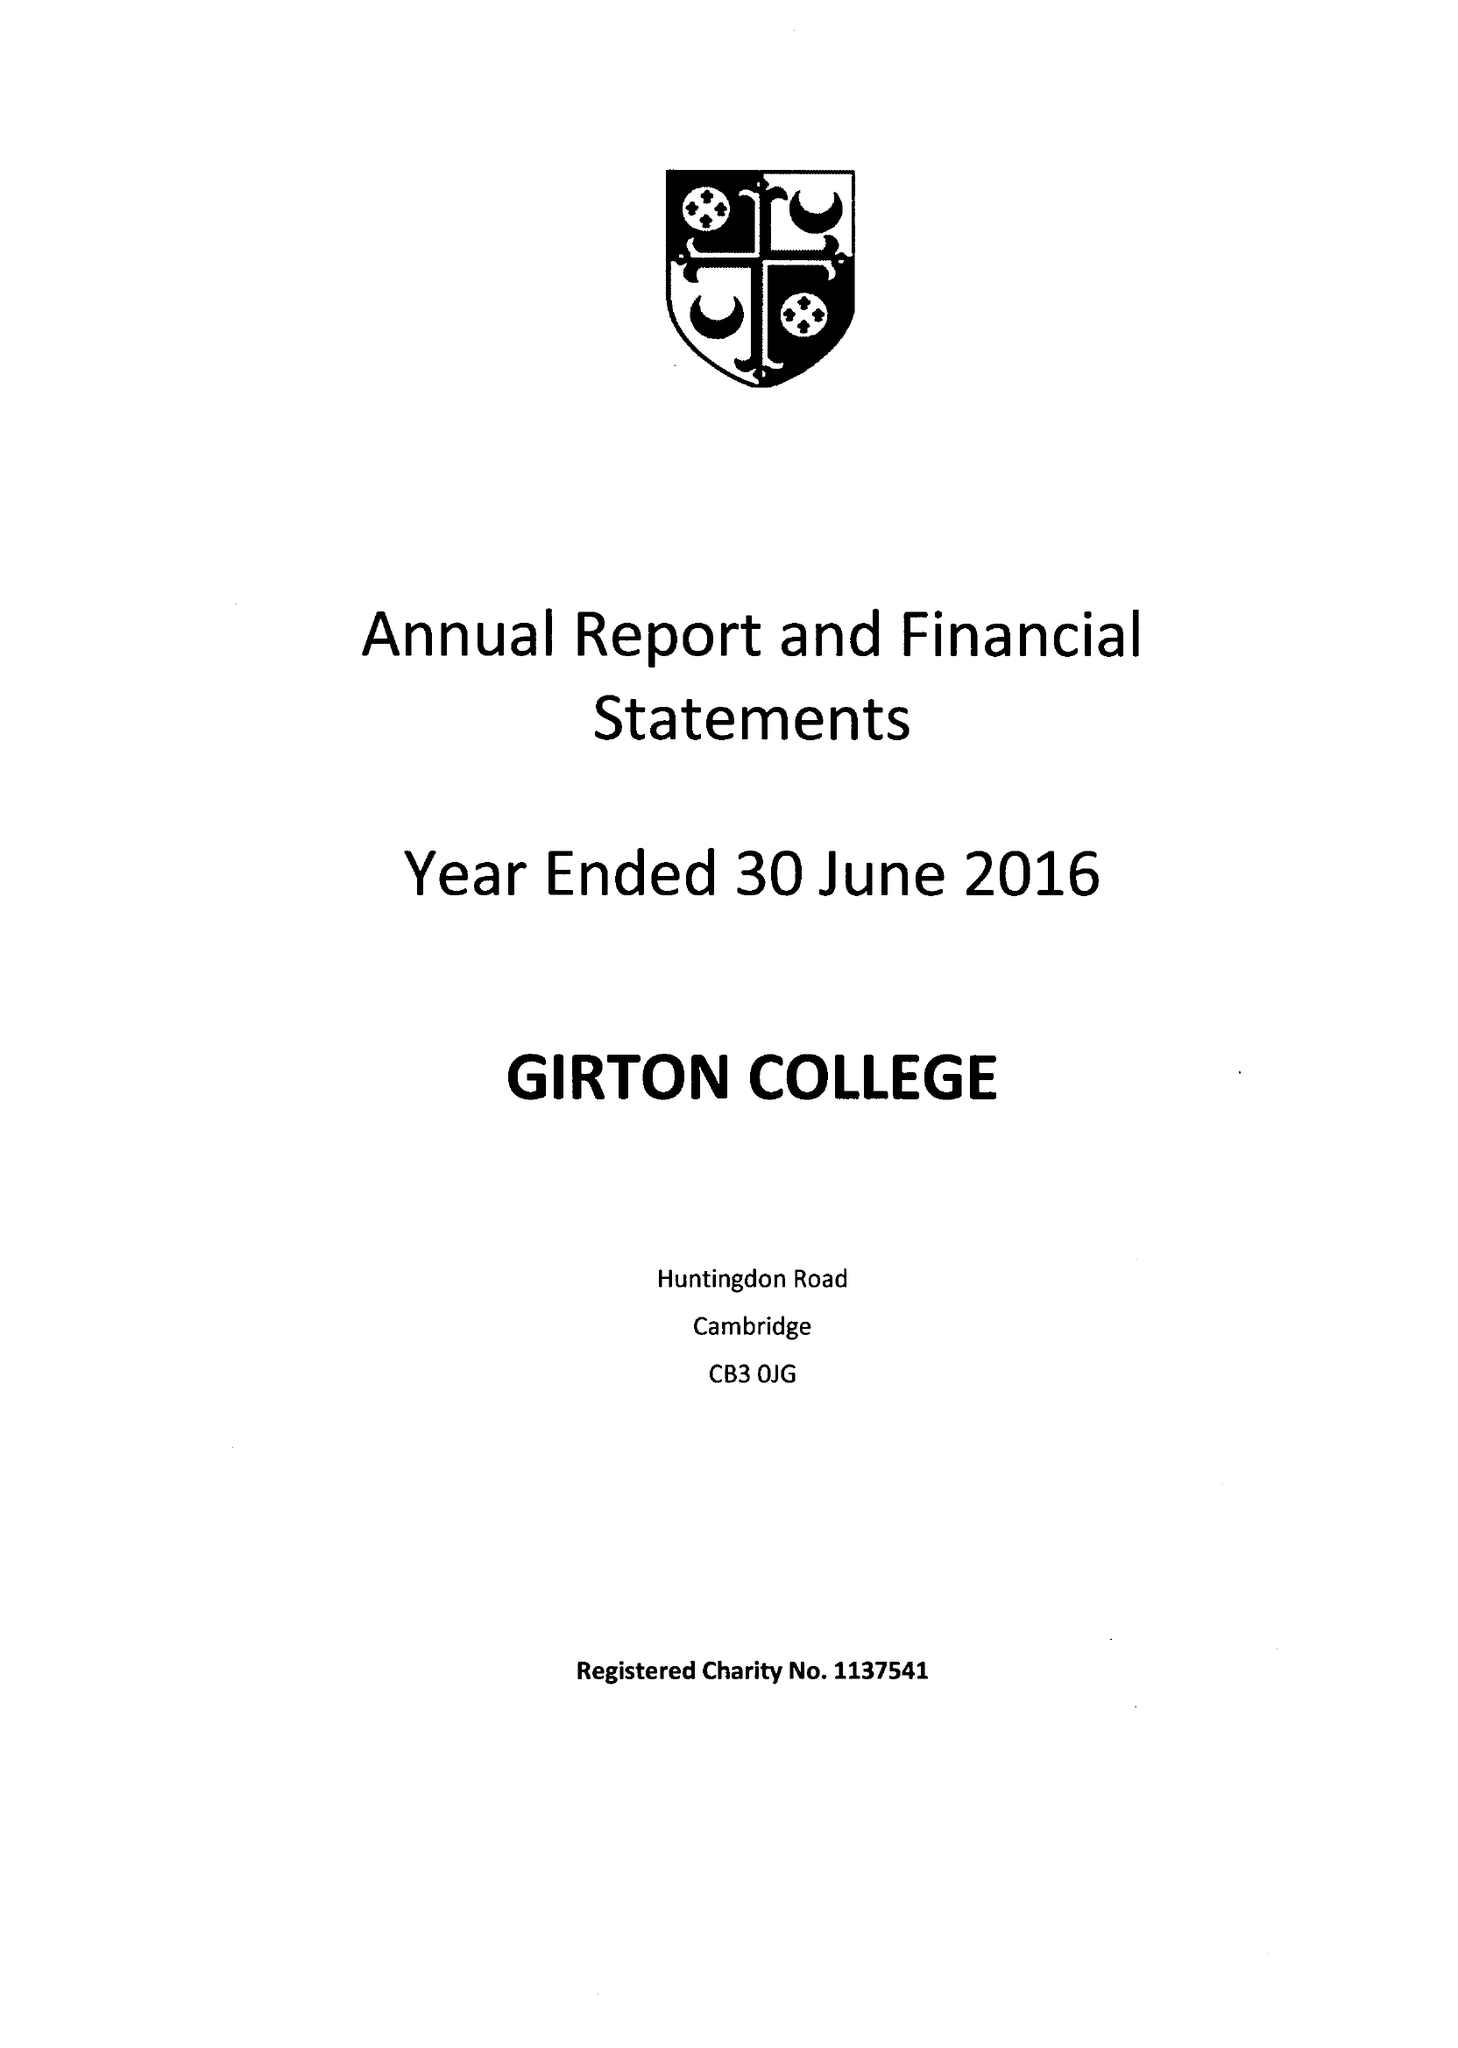What is the value for the address__postcode?
Answer the question using a single word or phrase. CB3 0JG 